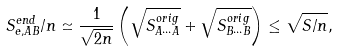<formula> <loc_0><loc_0><loc_500><loc_500>S _ { e , A B } ^ { e n d } / n \simeq \frac { 1 } { \sqrt { 2 n } } \left ( \sqrt { S ^ { o r i g } _ { A \cdots A } } + \sqrt { S ^ { o r i g } _ { B \cdots B } } \right ) \leq \sqrt { S / n } ,</formula> 